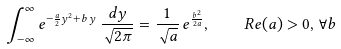<formula> <loc_0><loc_0><loc_500><loc_500>\int _ { - \infty } ^ { \infty } e ^ { - \frac { a } { 2 } y ^ { 2 } + b \, y } \, \frac { d y } { \sqrt { 2 \pi } } = \frac { 1 } { \sqrt { a } } \, e ^ { \frac { b ^ { 2 } } { 2 a } } , \quad R e { ( a ) } > 0 , \, \forall b</formula> 